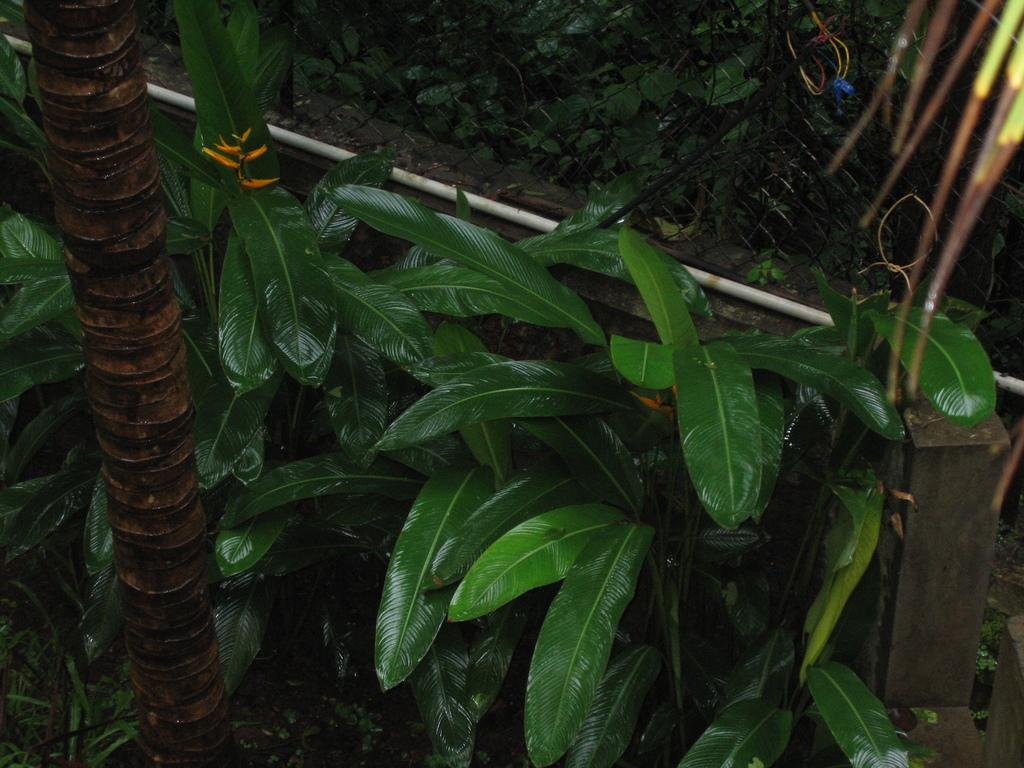What type of living organisms can be seen in the image? Plants are visible in the image. What part of a tree can be seen in the image? The trunk of a tree is visible in the image. What is the color of the object on the right side of the image? There is a white colored object in the image. What type of barrier is present in the image? There is a fence in the image. Can you see a needle threaded through the fence in the image? There is no needle or thread present in the image; it only features plants, a tree trunk, a white object, and a fence. 